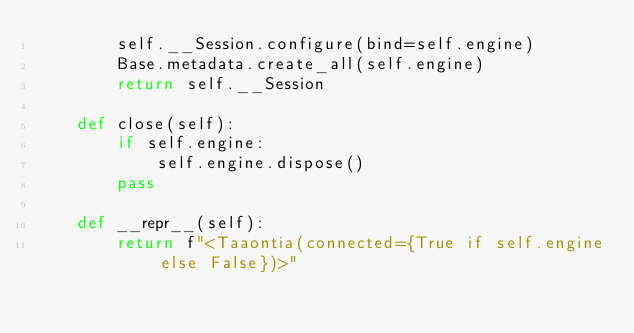<code> <loc_0><loc_0><loc_500><loc_500><_Python_>        self.__Session.configure(bind=self.engine)
        Base.metadata.create_all(self.engine)
        return self.__Session

    def close(self):
        if self.engine:
            self.engine.dispose()
        pass

    def __repr__(self):
        return f"<Taaontia(connected={True if self.engine else False})>"

</code> 